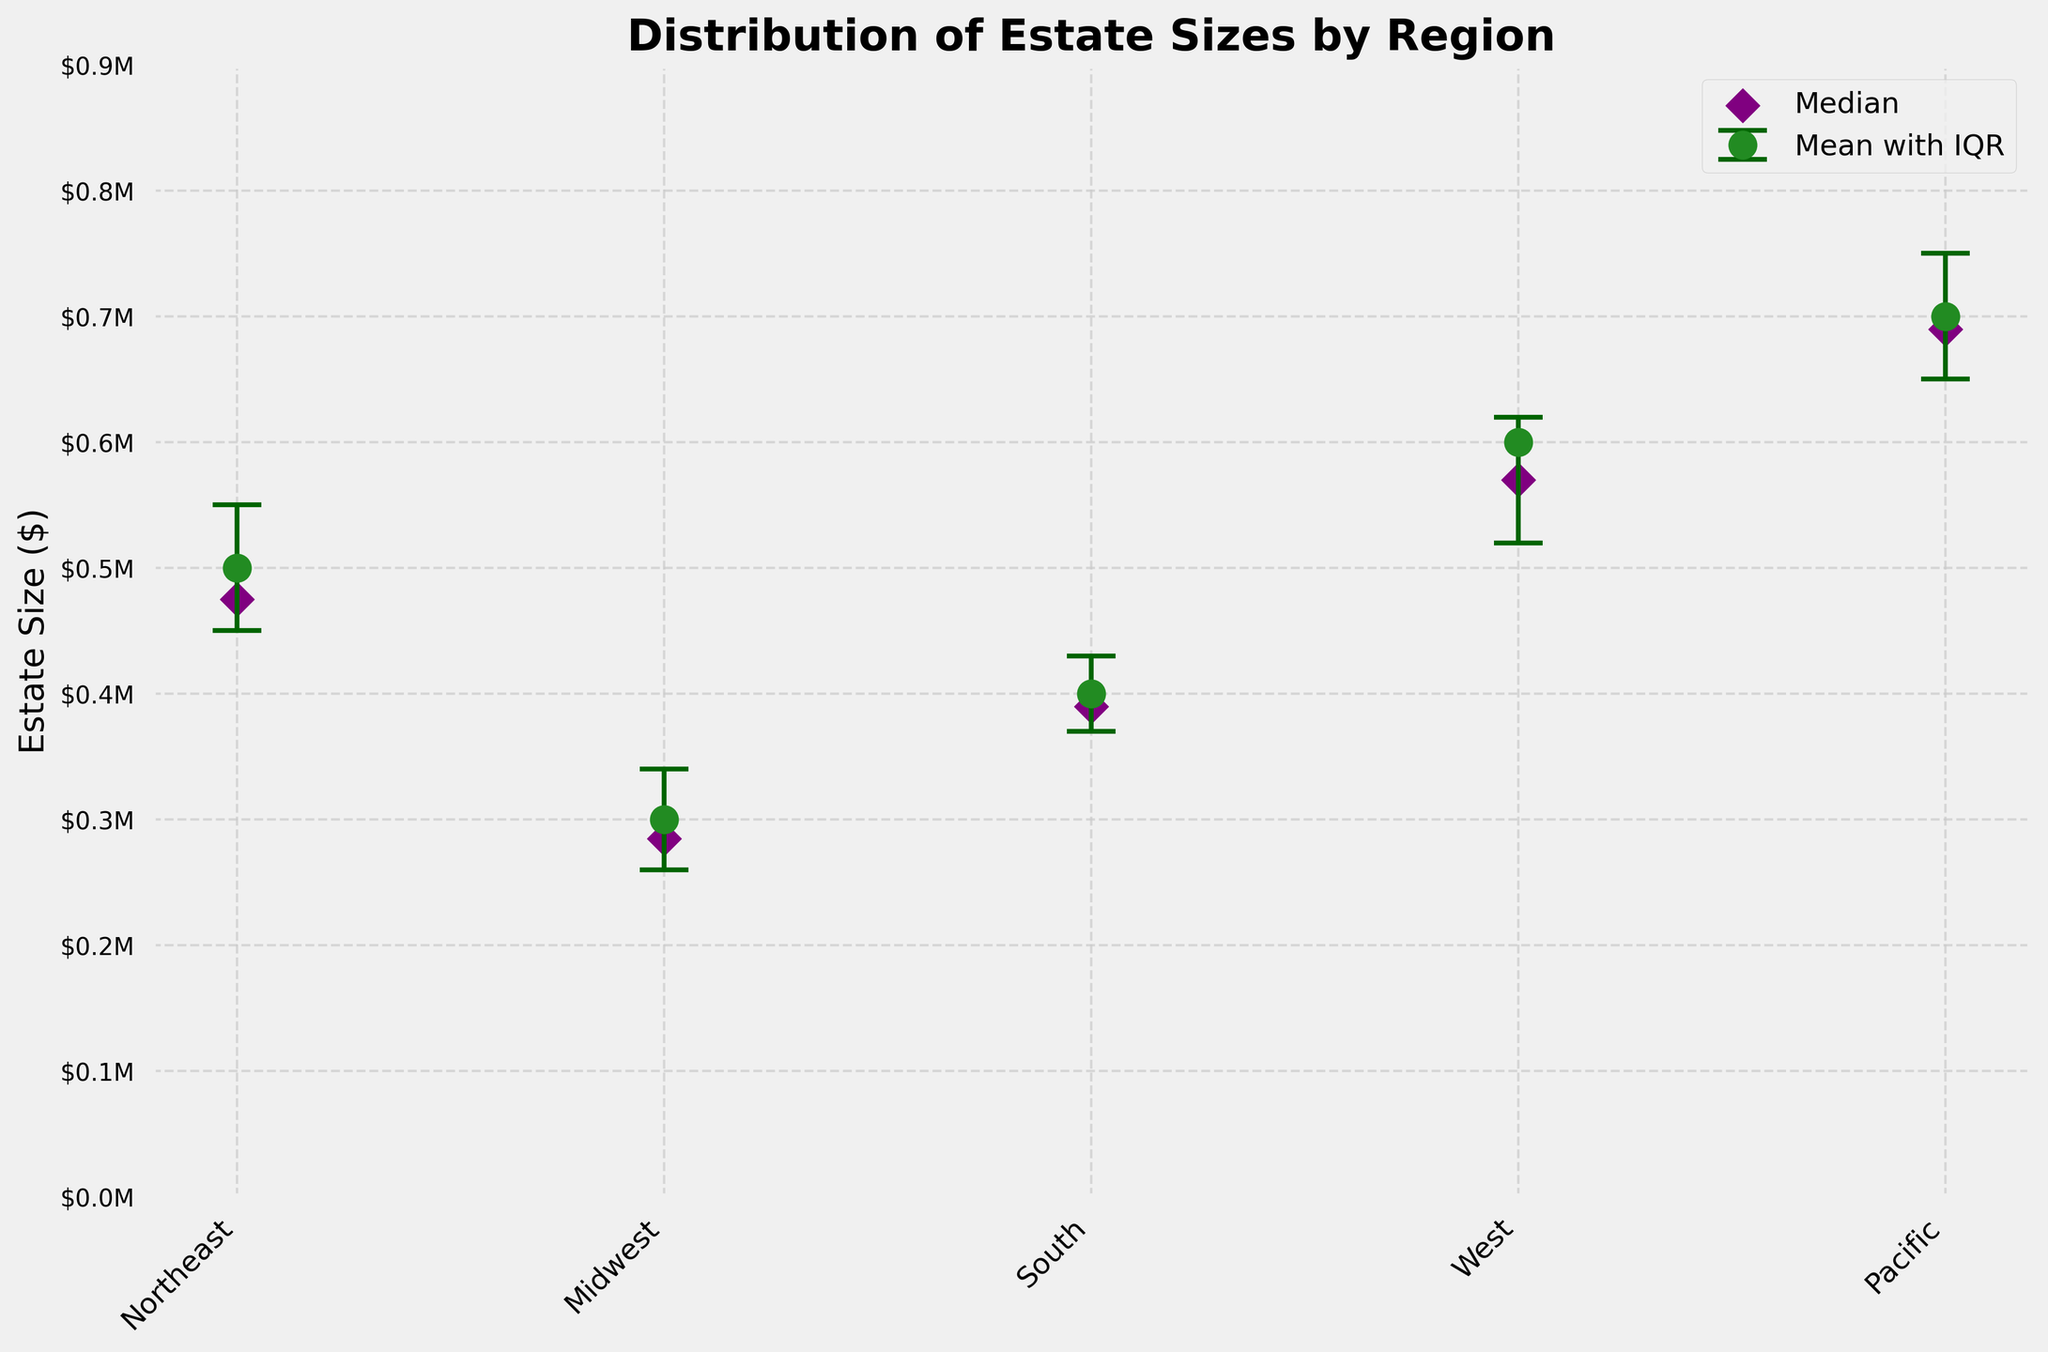What is the title of the plot? The title of the plot is typically displayed at the top of the figure.
Answer: Distribution of Estate Sizes by Region How many regions are presented in the figure? You can count the number of x-ticks or data points on the x-axis to find out the number of regions.
Answer: 5 Which region has the largest mean estate size? The vertical position of the data points represents the mean estate sizes, and the Pacific region has the highest point.
Answer: Pacific Which region has the smallest mean estate size? By comparing the vertical positions of the data points, the Midwest region is the lowest.
Answer: Midwest What do the error bars represent in this figure? The error bars in this figure represent the interquartile ranges (IQR) of estate sizes.
Answer: Interquartile ranges What is the median estate size in the West region? The median values are marked by diamond-shaped points. The West's median is found by locating the corresponding diamond on the y-axis.
Answer: $570,000 What is the range of the interquartile range (IQR) for the Northeast region? The IQR range can be found by subtracting the lower quartile value from the upper quartile value for the Northeast.
Answer: $100,000 Which region has the smallest difference between its mean and median estate sizes? Evaluating the vertical difference between the circle (mean) and the diamond (median) markers for each region shows that the Pacific has the smallest difference.
Answer: Pacific How does the median estate size in the South region compare to the mean estate size in the Midwest region? By locating the median diamond in the South and mean circle in the Midwest on the y-axis, the South's median ($390,000) is higher than the Midwest's mean ($300,000).
Answer: South's median is higher Which region has the widest interquartile range (IQR)? The region with the longest error bars represents the widest IQR. The Pacific region's error bars span the largest extent.
Answer: Pacific 